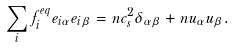Convert formula to latex. <formula><loc_0><loc_0><loc_500><loc_500>\sum _ { i } f _ { i } ^ { e q } e _ { i \alpha } e _ { i \beta } = n c _ { s } ^ { 2 } \delta _ { \alpha \beta } + n u _ { \alpha } u _ { \beta } .</formula> 